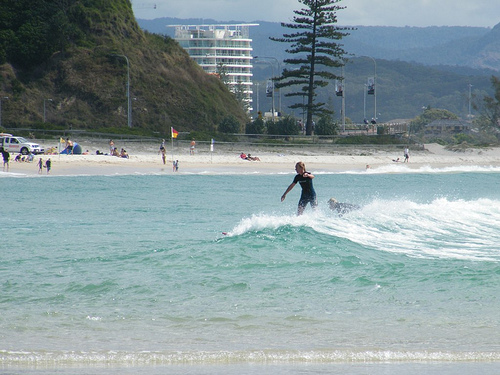Please provide a short description for this region: [0.71, 0.5, 0.97, 0.69]. The specified region [0.71, 0.5, 0.97, 0.69] of the image features a small wave curling over the ocean, indicative of a tranquil seaside scene with gentle surf. 